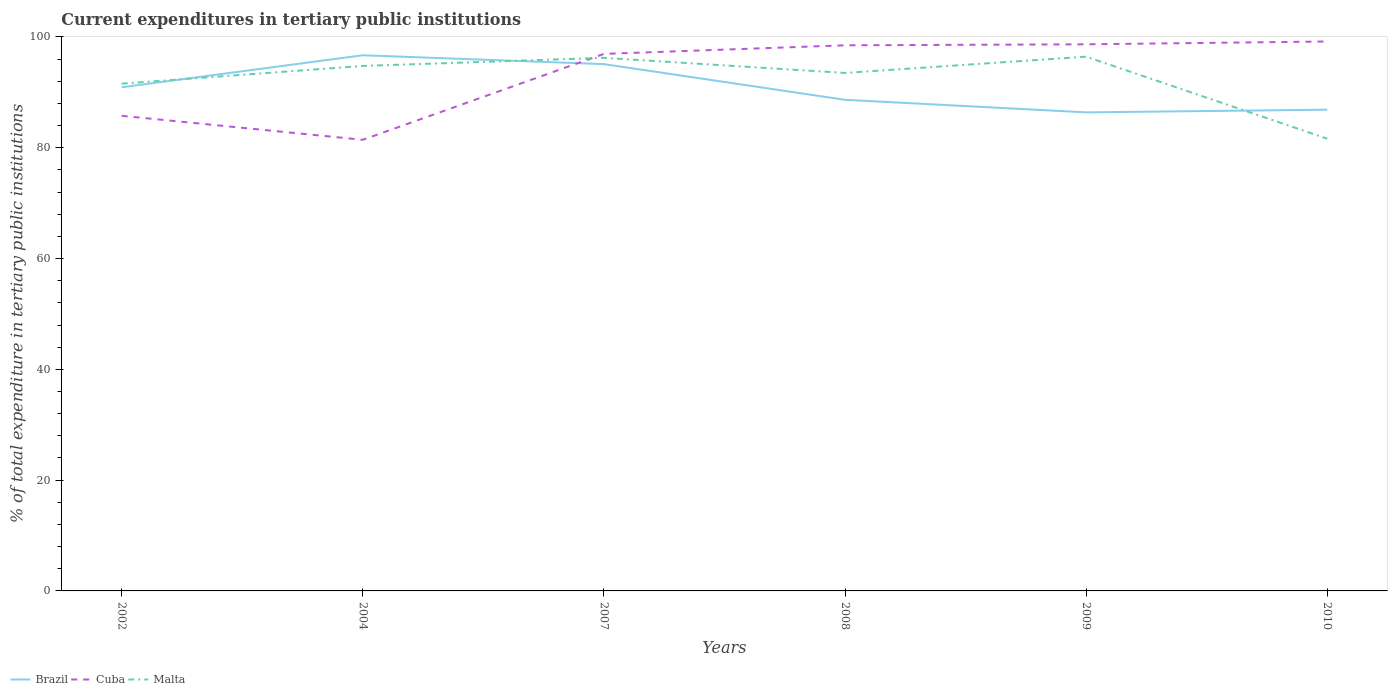How many different coloured lines are there?
Offer a terse response. 3. Is the number of lines equal to the number of legend labels?
Your answer should be compact. Yes. Across all years, what is the maximum current expenditures in tertiary public institutions in Cuba?
Offer a terse response. 81.44. What is the total current expenditures in tertiary public institutions in Malta in the graph?
Provide a short and direct response. 13.13. What is the difference between the highest and the second highest current expenditures in tertiary public institutions in Malta?
Ensure brevity in your answer.  14.81. What is the difference between the highest and the lowest current expenditures in tertiary public institutions in Malta?
Offer a very short reply. 4. Is the current expenditures in tertiary public institutions in Malta strictly greater than the current expenditures in tertiary public institutions in Brazil over the years?
Your answer should be compact. No. What is the difference between two consecutive major ticks on the Y-axis?
Your response must be concise. 20. Does the graph contain any zero values?
Offer a terse response. No. How many legend labels are there?
Give a very brief answer. 3. What is the title of the graph?
Your response must be concise. Current expenditures in tertiary public institutions. What is the label or title of the X-axis?
Offer a very short reply. Years. What is the label or title of the Y-axis?
Keep it short and to the point. % of total expenditure in tertiary public institutions. What is the % of total expenditure in tertiary public institutions of Brazil in 2002?
Offer a terse response. 90.92. What is the % of total expenditure in tertiary public institutions of Cuba in 2002?
Your answer should be compact. 85.77. What is the % of total expenditure in tertiary public institutions of Malta in 2002?
Ensure brevity in your answer.  91.57. What is the % of total expenditure in tertiary public institutions of Brazil in 2004?
Provide a succinct answer. 96.7. What is the % of total expenditure in tertiary public institutions in Cuba in 2004?
Your response must be concise. 81.44. What is the % of total expenditure in tertiary public institutions in Malta in 2004?
Make the answer very short. 94.77. What is the % of total expenditure in tertiary public institutions of Brazil in 2007?
Offer a very short reply. 95.09. What is the % of total expenditure in tertiary public institutions in Cuba in 2007?
Your answer should be very brief. 96.94. What is the % of total expenditure in tertiary public institutions in Malta in 2007?
Give a very brief answer. 96.23. What is the % of total expenditure in tertiary public institutions in Brazil in 2008?
Keep it short and to the point. 88.65. What is the % of total expenditure in tertiary public institutions of Cuba in 2008?
Ensure brevity in your answer.  98.49. What is the % of total expenditure in tertiary public institutions in Malta in 2008?
Your answer should be very brief. 93.5. What is the % of total expenditure in tertiary public institutions in Brazil in 2009?
Provide a short and direct response. 86.39. What is the % of total expenditure in tertiary public institutions in Cuba in 2009?
Give a very brief answer. 98.67. What is the % of total expenditure in tertiary public institutions in Malta in 2009?
Your answer should be compact. 96.44. What is the % of total expenditure in tertiary public institutions of Brazil in 2010?
Offer a terse response. 86.87. What is the % of total expenditure in tertiary public institutions in Cuba in 2010?
Your response must be concise. 99.18. What is the % of total expenditure in tertiary public institutions of Malta in 2010?
Keep it short and to the point. 81.63. Across all years, what is the maximum % of total expenditure in tertiary public institutions of Brazil?
Give a very brief answer. 96.7. Across all years, what is the maximum % of total expenditure in tertiary public institutions in Cuba?
Ensure brevity in your answer.  99.18. Across all years, what is the maximum % of total expenditure in tertiary public institutions in Malta?
Your answer should be very brief. 96.44. Across all years, what is the minimum % of total expenditure in tertiary public institutions of Brazil?
Your answer should be very brief. 86.39. Across all years, what is the minimum % of total expenditure in tertiary public institutions of Cuba?
Make the answer very short. 81.44. Across all years, what is the minimum % of total expenditure in tertiary public institutions in Malta?
Offer a very short reply. 81.63. What is the total % of total expenditure in tertiary public institutions in Brazil in the graph?
Provide a succinct answer. 544.62. What is the total % of total expenditure in tertiary public institutions of Cuba in the graph?
Offer a terse response. 560.49. What is the total % of total expenditure in tertiary public institutions of Malta in the graph?
Your answer should be compact. 554.14. What is the difference between the % of total expenditure in tertiary public institutions of Brazil in 2002 and that in 2004?
Give a very brief answer. -5.78. What is the difference between the % of total expenditure in tertiary public institutions of Cuba in 2002 and that in 2004?
Your response must be concise. 4.33. What is the difference between the % of total expenditure in tertiary public institutions in Malta in 2002 and that in 2004?
Keep it short and to the point. -3.2. What is the difference between the % of total expenditure in tertiary public institutions in Brazil in 2002 and that in 2007?
Keep it short and to the point. -4.18. What is the difference between the % of total expenditure in tertiary public institutions in Cuba in 2002 and that in 2007?
Ensure brevity in your answer.  -11.17. What is the difference between the % of total expenditure in tertiary public institutions of Malta in 2002 and that in 2007?
Your answer should be very brief. -4.66. What is the difference between the % of total expenditure in tertiary public institutions in Brazil in 2002 and that in 2008?
Ensure brevity in your answer.  2.26. What is the difference between the % of total expenditure in tertiary public institutions in Cuba in 2002 and that in 2008?
Provide a succinct answer. -12.72. What is the difference between the % of total expenditure in tertiary public institutions of Malta in 2002 and that in 2008?
Your answer should be very brief. -1.94. What is the difference between the % of total expenditure in tertiary public institutions in Brazil in 2002 and that in 2009?
Offer a very short reply. 4.53. What is the difference between the % of total expenditure in tertiary public institutions in Cuba in 2002 and that in 2009?
Your answer should be very brief. -12.9. What is the difference between the % of total expenditure in tertiary public institutions in Malta in 2002 and that in 2009?
Provide a short and direct response. -4.87. What is the difference between the % of total expenditure in tertiary public institutions in Brazil in 2002 and that in 2010?
Keep it short and to the point. 4.05. What is the difference between the % of total expenditure in tertiary public institutions of Cuba in 2002 and that in 2010?
Your answer should be compact. -13.41. What is the difference between the % of total expenditure in tertiary public institutions of Malta in 2002 and that in 2010?
Give a very brief answer. 9.93. What is the difference between the % of total expenditure in tertiary public institutions of Brazil in 2004 and that in 2007?
Give a very brief answer. 1.6. What is the difference between the % of total expenditure in tertiary public institutions of Cuba in 2004 and that in 2007?
Keep it short and to the point. -15.51. What is the difference between the % of total expenditure in tertiary public institutions in Malta in 2004 and that in 2007?
Keep it short and to the point. -1.46. What is the difference between the % of total expenditure in tertiary public institutions of Brazil in 2004 and that in 2008?
Offer a terse response. 8.04. What is the difference between the % of total expenditure in tertiary public institutions in Cuba in 2004 and that in 2008?
Offer a very short reply. -17.06. What is the difference between the % of total expenditure in tertiary public institutions of Malta in 2004 and that in 2008?
Offer a terse response. 1.26. What is the difference between the % of total expenditure in tertiary public institutions of Brazil in 2004 and that in 2009?
Your answer should be compact. 10.31. What is the difference between the % of total expenditure in tertiary public institutions in Cuba in 2004 and that in 2009?
Offer a very short reply. -17.24. What is the difference between the % of total expenditure in tertiary public institutions in Malta in 2004 and that in 2009?
Your response must be concise. -1.67. What is the difference between the % of total expenditure in tertiary public institutions of Brazil in 2004 and that in 2010?
Your answer should be compact. 9.83. What is the difference between the % of total expenditure in tertiary public institutions in Cuba in 2004 and that in 2010?
Offer a very short reply. -17.75. What is the difference between the % of total expenditure in tertiary public institutions in Malta in 2004 and that in 2010?
Give a very brief answer. 13.13. What is the difference between the % of total expenditure in tertiary public institutions of Brazil in 2007 and that in 2008?
Provide a succinct answer. 6.44. What is the difference between the % of total expenditure in tertiary public institutions in Cuba in 2007 and that in 2008?
Make the answer very short. -1.55. What is the difference between the % of total expenditure in tertiary public institutions in Malta in 2007 and that in 2008?
Make the answer very short. 2.73. What is the difference between the % of total expenditure in tertiary public institutions in Brazil in 2007 and that in 2009?
Offer a terse response. 8.71. What is the difference between the % of total expenditure in tertiary public institutions of Cuba in 2007 and that in 2009?
Your response must be concise. -1.73. What is the difference between the % of total expenditure in tertiary public institutions in Malta in 2007 and that in 2009?
Keep it short and to the point. -0.21. What is the difference between the % of total expenditure in tertiary public institutions in Brazil in 2007 and that in 2010?
Provide a succinct answer. 8.22. What is the difference between the % of total expenditure in tertiary public institutions of Cuba in 2007 and that in 2010?
Your answer should be compact. -2.24. What is the difference between the % of total expenditure in tertiary public institutions in Malta in 2007 and that in 2010?
Keep it short and to the point. 14.6. What is the difference between the % of total expenditure in tertiary public institutions in Brazil in 2008 and that in 2009?
Ensure brevity in your answer.  2.27. What is the difference between the % of total expenditure in tertiary public institutions in Cuba in 2008 and that in 2009?
Give a very brief answer. -0.18. What is the difference between the % of total expenditure in tertiary public institutions of Malta in 2008 and that in 2009?
Offer a very short reply. -2.94. What is the difference between the % of total expenditure in tertiary public institutions of Brazil in 2008 and that in 2010?
Your response must be concise. 1.78. What is the difference between the % of total expenditure in tertiary public institutions of Cuba in 2008 and that in 2010?
Give a very brief answer. -0.69. What is the difference between the % of total expenditure in tertiary public institutions of Malta in 2008 and that in 2010?
Provide a short and direct response. 11.87. What is the difference between the % of total expenditure in tertiary public institutions of Brazil in 2009 and that in 2010?
Your response must be concise. -0.48. What is the difference between the % of total expenditure in tertiary public institutions of Cuba in 2009 and that in 2010?
Provide a short and direct response. -0.51. What is the difference between the % of total expenditure in tertiary public institutions of Malta in 2009 and that in 2010?
Offer a terse response. 14.81. What is the difference between the % of total expenditure in tertiary public institutions of Brazil in 2002 and the % of total expenditure in tertiary public institutions of Cuba in 2004?
Provide a succinct answer. 9.48. What is the difference between the % of total expenditure in tertiary public institutions in Brazil in 2002 and the % of total expenditure in tertiary public institutions in Malta in 2004?
Make the answer very short. -3.85. What is the difference between the % of total expenditure in tertiary public institutions of Cuba in 2002 and the % of total expenditure in tertiary public institutions of Malta in 2004?
Provide a short and direct response. -9. What is the difference between the % of total expenditure in tertiary public institutions in Brazil in 2002 and the % of total expenditure in tertiary public institutions in Cuba in 2007?
Ensure brevity in your answer.  -6.03. What is the difference between the % of total expenditure in tertiary public institutions of Brazil in 2002 and the % of total expenditure in tertiary public institutions of Malta in 2007?
Your response must be concise. -5.31. What is the difference between the % of total expenditure in tertiary public institutions of Cuba in 2002 and the % of total expenditure in tertiary public institutions of Malta in 2007?
Ensure brevity in your answer.  -10.46. What is the difference between the % of total expenditure in tertiary public institutions of Brazil in 2002 and the % of total expenditure in tertiary public institutions of Cuba in 2008?
Your response must be concise. -7.58. What is the difference between the % of total expenditure in tertiary public institutions in Brazil in 2002 and the % of total expenditure in tertiary public institutions in Malta in 2008?
Offer a terse response. -2.59. What is the difference between the % of total expenditure in tertiary public institutions of Cuba in 2002 and the % of total expenditure in tertiary public institutions of Malta in 2008?
Keep it short and to the point. -7.74. What is the difference between the % of total expenditure in tertiary public institutions of Brazil in 2002 and the % of total expenditure in tertiary public institutions of Cuba in 2009?
Make the answer very short. -7.76. What is the difference between the % of total expenditure in tertiary public institutions in Brazil in 2002 and the % of total expenditure in tertiary public institutions in Malta in 2009?
Give a very brief answer. -5.52. What is the difference between the % of total expenditure in tertiary public institutions in Cuba in 2002 and the % of total expenditure in tertiary public institutions in Malta in 2009?
Make the answer very short. -10.67. What is the difference between the % of total expenditure in tertiary public institutions of Brazil in 2002 and the % of total expenditure in tertiary public institutions of Cuba in 2010?
Offer a terse response. -8.26. What is the difference between the % of total expenditure in tertiary public institutions in Brazil in 2002 and the % of total expenditure in tertiary public institutions in Malta in 2010?
Give a very brief answer. 9.28. What is the difference between the % of total expenditure in tertiary public institutions of Cuba in 2002 and the % of total expenditure in tertiary public institutions of Malta in 2010?
Keep it short and to the point. 4.14. What is the difference between the % of total expenditure in tertiary public institutions in Brazil in 2004 and the % of total expenditure in tertiary public institutions in Cuba in 2007?
Provide a succinct answer. -0.24. What is the difference between the % of total expenditure in tertiary public institutions in Brazil in 2004 and the % of total expenditure in tertiary public institutions in Malta in 2007?
Give a very brief answer. 0.47. What is the difference between the % of total expenditure in tertiary public institutions in Cuba in 2004 and the % of total expenditure in tertiary public institutions in Malta in 2007?
Offer a very short reply. -14.79. What is the difference between the % of total expenditure in tertiary public institutions in Brazil in 2004 and the % of total expenditure in tertiary public institutions in Cuba in 2008?
Give a very brief answer. -1.8. What is the difference between the % of total expenditure in tertiary public institutions of Brazil in 2004 and the % of total expenditure in tertiary public institutions of Malta in 2008?
Your response must be concise. 3.19. What is the difference between the % of total expenditure in tertiary public institutions in Cuba in 2004 and the % of total expenditure in tertiary public institutions in Malta in 2008?
Ensure brevity in your answer.  -12.07. What is the difference between the % of total expenditure in tertiary public institutions in Brazil in 2004 and the % of total expenditure in tertiary public institutions in Cuba in 2009?
Give a very brief answer. -1.98. What is the difference between the % of total expenditure in tertiary public institutions of Brazil in 2004 and the % of total expenditure in tertiary public institutions of Malta in 2009?
Make the answer very short. 0.26. What is the difference between the % of total expenditure in tertiary public institutions of Cuba in 2004 and the % of total expenditure in tertiary public institutions of Malta in 2009?
Keep it short and to the point. -15.01. What is the difference between the % of total expenditure in tertiary public institutions of Brazil in 2004 and the % of total expenditure in tertiary public institutions of Cuba in 2010?
Ensure brevity in your answer.  -2.48. What is the difference between the % of total expenditure in tertiary public institutions in Brazil in 2004 and the % of total expenditure in tertiary public institutions in Malta in 2010?
Provide a succinct answer. 15.06. What is the difference between the % of total expenditure in tertiary public institutions in Cuba in 2004 and the % of total expenditure in tertiary public institutions in Malta in 2010?
Give a very brief answer. -0.2. What is the difference between the % of total expenditure in tertiary public institutions of Brazil in 2007 and the % of total expenditure in tertiary public institutions of Cuba in 2008?
Keep it short and to the point. -3.4. What is the difference between the % of total expenditure in tertiary public institutions in Brazil in 2007 and the % of total expenditure in tertiary public institutions in Malta in 2008?
Your response must be concise. 1.59. What is the difference between the % of total expenditure in tertiary public institutions of Cuba in 2007 and the % of total expenditure in tertiary public institutions of Malta in 2008?
Make the answer very short. 3.44. What is the difference between the % of total expenditure in tertiary public institutions in Brazil in 2007 and the % of total expenditure in tertiary public institutions in Cuba in 2009?
Your answer should be compact. -3.58. What is the difference between the % of total expenditure in tertiary public institutions in Brazil in 2007 and the % of total expenditure in tertiary public institutions in Malta in 2009?
Provide a succinct answer. -1.35. What is the difference between the % of total expenditure in tertiary public institutions of Cuba in 2007 and the % of total expenditure in tertiary public institutions of Malta in 2009?
Offer a very short reply. 0.5. What is the difference between the % of total expenditure in tertiary public institutions of Brazil in 2007 and the % of total expenditure in tertiary public institutions of Cuba in 2010?
Ensure brevity in your answer.  -4.09. What is the difference between the % of total expenditure in tertiary public institutions in Brazil in 2007 and the % of total expenditure in tertiary public institutions in Malta in 2010?
Keep it short and to the point. 13.46. What is the difference between the % of total expenditure in tertiary public institutions in Cuba in 2007 and the % of total expenditure in tertiary public institutions in Malta in 2010?
Your answer should be compact. 15.31. What is the difference between the % of total expenditure in tertiary public institutions of Brazil in 2008 and the % of total expenditure in tertiary public institutions of Cuba in 2009?
Provide a succinct answer. -10.02. What is the difference between the % of total expenditure in tertiary public institutions of Brazil in 2008 and the % of total expenditure in tertiary public institutions of Malta in 2009?
Your answer should be very brief. -7.79. What is the difference between the % of total expenditure in tertiary public institutions in Cuba in 2008 and the % of total expenditure in tertiary public institutions in Malta in 2009?
Make the answer very short. 2.05. What is the difference between the % of total expenditure in tertiary public institutions in Brazil in 2008 and the % of total expenditure in tertiary public institutions in Cuba in 2010?
Your answer should be very brief. -10.53. What is the difference between the % of total expenditure in tertiary public institutions of Brazil in 2008 and the % of total expenditure in tertiary public institutions of Malta in 2010?
Provide a short and direct response. 7.02. What is the difference between the % of total expenditure in tertiary public institutions in Cuba in 2008 and the % of total expenditure in tertiary public institutions in Malta in 2010?
Your answer should be compact. 16.86. What is the difference between the % of total expenditure in tertiary public institutions of Brazil in 2009 and the % of total expenditure in tertiary public institutions of Cuba in 2010?
Give a very brief answer. -12.79. What is the difference between the % of total expenditure in tertiary public institutions in Brazil in 2009 and the % of total expenditure in tertiary public institutions in Malta in 2010?
Make the answer very short. 4.75. What is the difference between the % of total expenditure in tertiary public institutions of Cuba in 2009 and the % of total expenditure in tertiary public institutions of Malta in 2010?
Offer a terse response. 17.04. What is the average % of total expenditure in tertiary public institutions in Brazil per year?
Your answer should be compact. 90.77. What is the average % of total expenditure in tertiary public institutions of Cuba per year?
Keep it short and to the point. 93.42. What is the average % of total expenditure in tertiary public institutions in Malta per year?
Your response must be concise. 92.36. In the year 2002, what is the difference between the % of total expenditure in tertiary public institutions of Brazil and % of total expenditure in tertiary public institutions of Cuba?
Make the answer very short. 5.15. In the year 2002, what is the difference between the % of total expenditure in tertiary public institutions in Brazil and % of total expenditure in tertiary public institutions in Malta?
Offer a terse response. -0.65. In the year 2002, what is the difference between the % of total expenditure in tertiary public institutions in Cuba and % of total expenditure in tertiary public institutions in Malta?
Give a very brief answer. -5.8. In the year 2004, what is the difference between the % of total expenditure in tertiary public institutions in Brazil and % of total expenditure in tertiary public institutions in Cuba?
Your answer should be very brief. 15.26. In the year 2004, what is the difference between the % of total expenditure in tertiary public institutions in Brazil and % of total expenditure in tertiary public institutions in Malta?
Offer a very short reply. 1.93. In the year 2004, what is the difference between the % of total expenditure in tertiary public institutions of Cuba and % of total expenditure in tertiary public institutions of Malta?
Offer a very short reply. -13.33. In the year 2007, what is the difference between the % of total expenditure in tertiary public institutions of Brazil and % of total expenditure in tertiary public institutions of Cuba?
Provide a short and direct response. -1.85. In the year 2007, what is the difference between the % of total expenditure in tertiary public institutions in Brazil and % of total expenditure in tertiary public institutions in Malta?
Give a very brief answer. -1.14. In the year 2007, what is the difference between the % of total expenditure in tertiary public institutions of Cuba and % of total expenditure in tertiary public institutions of Malta?
Give a very brief answer. 0.71. In the year 2008, what is the difference between the % of total expenditure in tertiary public institutions of Brazil and % of total expenditure in tertiary public institutions of Cuba?
Give a very brief answer. -9.84. In the year 2008, what is the difference between the % of total expenditure in tertiary public institutions in Brazil and % of total expenditure in tertiary public institutions in Malta?
Offer a terse response. -4.85. In the year 2008, what is the difference between the % of total expenditure in tertiary public institutions in Cuba and % of total expenditure in tertiary public institutions in Malta?
Your response must be concise. 4.99. In the year 2009, what is the difference between the % of total expenditure in tertiary public institutions of Brazil and % of total expenditure in tertiary public institutions of Cuba?
Give a very brief answer. -12.29. In the year 2009, what is the difference between the % of total expenditure in tertiary public institutions in Brazil and % of total expenditure in tertiary public institutions in Malta?
Your answer should be very brief. -10.05. In the year 2009, what is the difference between the % of total expenditure in tertiary public institutions of Cuba and % of total expenditure in tertiary public institutions of Malta?
Ensure brevity in your answer.  2.23. In the year 2010, what is the difference between the % of total expenditure in tertiary public institutions of Brazil and % of total expenditure in tertiary public institutions of Cuba?
Ensure brevity in your answer.  -12.31. In the year 2010, what is the difference between the % of total expenditure in tertiary public institutions of Brazil and % of total expenditure in tertiary public institutions of Malta?
Your answer should be compact. 5.24. In the year 2010, what is the difference between the % of total expenditure in tertiary public institutions in Cuba and % of total expenditure in tertiary public institutions in Malta?
Make the answer very short. 17.55. What is the ratio of the % of total expenditure in tertiary public institutions in Brazil in 2002 to that in 2004?
Make the answer very short. 0.94. What is the ratio of the % of total expenditure in tertiary public institutions in Cuba in 2002 to that in 2004?
Give a very brief answer. 1.05. What is the ratio of the % of total expenditure in tertiary public institutions in Malta in 2002 to that in 2004?
Make the answer very short. 0.97. What is the ratio of the % of total expenditure in tertiary public institutions of Brazil in 2002 to that in 2007?
Your answer should be compact. 0.96. What is the ratio of the % of total expenditure in tertiary public institutions in Cuba in 2002 to that in 2007?
Give a very brief answer. 0.88. What is the ratio of the % of total expenditure in tertiary public institutions of Malta in 2002 to that in 2007?
Give a very brief answer. 0.95. What is the ratio of the % of total expenditure in tertiary public institutions of Brazil in 2002 to that in 2008?
Your response must be concise. 1.03. What is the ratio of the % of total expenditure in tertiary public institutions of Cuba in 2002 to that in 2008?
Your answer should be compact. 0.87. What is the ratio of the % of total expenditure in tertiary public institutions in Malta in 2002 to that in 2008?
Make the answer very short. 0.98. What is the ratio of the % of total expenditure in tertiary public institutions in Brazil in 2002 to that in 2009?
Keep it short and to the point. 1.05. What is the ratio of the % of total expenditure in tertiary public institutions in Cuba in 2002 to that in 2009?
Offer a terse response. 0.87. What is the ratio of the % of total expenditure in tertiary public institutions of Malta in 2002 to that in 2009?
Your answer should be very brief. 0.95. What is the ratio of the % of total expenditure in tertiary public institutions in Brazil in 2002 to that in 2010?
Provide a short and direct response. 1.05. What is the ratio of the % of total expenditure in tertiary public institutions in Cuba in 2002 to that in 2010?
Provide a short and direct response. 0.86. What is the ratio of the % of total expenditure in tertiary public institutions of Malta in 2002 to that in 2010?
Offer a very short reply. 1.12. What is the ratio of the % of total expenditure in tertiary public institutions of Brazil in 2004 to that in 2007?
Your answer should be very brief. 1.02. What is the ratio of the % of total expenditure in tertiary public institutions in Cuba in 2004 to that in 2007?
Your response must be concise. 0.84. What is the ratio of the % of total expenditure in tertiary public institutions of Brazil in 2004 to that in 2008?
Your answer should be compact. 1.09. What is the ratio of the % of total expenditure in tertiary public institutions in Cuba in 2004 to that in 2008?
Offer a terse response. 0.83. What is the ratio of the % of total expenditure in tertiary public institutions in Malta in 2004 to that in 2008?
Give a very brief answer. 1.01. What is the ratio of the % of total expenditure in tertiary public institutions of Brazil in 2004 to that in 2009?
Offer a very short reply. 1.12. What is the ratio of the % of total expenditure in tertiary public institutions in Cuba in 2004 to that in 2009?
Ensure brevity in your answer.  0.83. What is the ratio of the % of total expenditure in tertiary public institutions in Malta in 2004 to that in 2009?
Your response must be concise. 0.98. What is the ratio of the % of total expenditure in tertiary public institutions in Brazil in 2004 to that in 2010?
Offer a very short reply. 1.11. What is the ratio of the % of total expenditure in tertiary public institutions of Cuba in 2004 to that in 2010?
Provide a short and direct response. 0.82. What is the ratio of the % of total expenditure in tertiary public institutions in Malta in 2004 to that in 2010?
Provide a short and direct response. 1.16. What is the ratio of the % of total expenditure in tertiary public institutions of Brazil in 2007 to that in 2008?
Your answer should be very brief. 1.07. What is the ratio of the % of total expenditure in tertiary public institutions of Cuba in 2007 to that in 2008?
Keep it short and to the point. 0.98. What is the ratio of the % of total expenditure in tertiary public institutions of Malta in 2007 to that in 2008?
Offer a very short reply. 1.03. What is the ratio of the % of total expenditure in tertiary public institutions of Brazil in 2007 to that in 2009?
Provide a short and direct response. 1.1. What is the ratio of the % of total expenditure in tertiary public institutions of Cuba in 2007 to that in 2009?
Offer a very short reply. 0.98. What is the ratio of the % of total expenditure in tertiary public institutions of Brazil in 2007 to that in 2010?
Your response must be concise. 1.09. What is the ratio of the % of total expenditure in tertiary public institutions in Cuba in 2007 to that in 2010?
Your answer should be very brief. 0.98. What is the ratio of the % of total expenditure in tertiary public institutions in Malta in 2007 to that in 2010?
Your answer should be very brief. 1.18. What is the ratio of the % of total expenditure in tertiary public institutions of Brazil in 2008 to that in 2009?
Ensure brevity in your answer.  1.03. What is the ratio of the % of total expenditure in tertiary public institutions in Cuba in 2008 to that in 2009?
Keep it short and to the point. 1. What is the ratio of the % of total expenditure in tertiary public institutions in Malta in 2008 to that in 2009?
Keep it short and to the point. 0.97. What is the ratio of the % of total expenditure in tertiary public institutions of Brazil in 2008 to that in 2010?
Ensure brevity in your answer.  1.02. What is the ratio of the % of total expenditure in tertiary public institutions of Cuba in 2008 to that in 2010?
Provide a short and direct response. 0.99. What is the ratio of the % of total expenditure in tertiary public institutions in Malta in 2008 to that in 2010?
Provide a short and direct response. 1.15. What is the ratio of the % of total expenditure in tertiary public institutions in Malta in 2009 to that in 2010?
Offer a very short reply. 1.18. What is the difference between the highest and the second highest % of total expenditure in tertiary public institutions in Brazil?
Give a very brief answer. 1.6. What is the difference between the highest and the second highest % of total expenditure in tertiary public institutions of Cuba?
Ensure brevity in your answer.  0.51. What is the difference between the highest and the second highest % of total expenditure in tertiary public institutions in Malta?
Your answer should be compact. 0.21. What is the difference between the highest and the lowest % of total expenditure in tertiary public institutions in Brazil?
Provide a succinct answer. 10.31. What is the difference between the highest and the lowest % of total expenditure in tertiary public institutions of Cuba?
Your answer should be very brief. 17.75. What is the difference between the highest and the lowest % of total expenditure in tertiary public institutions in Malta?
Provide a short and direct response. 14.81. 